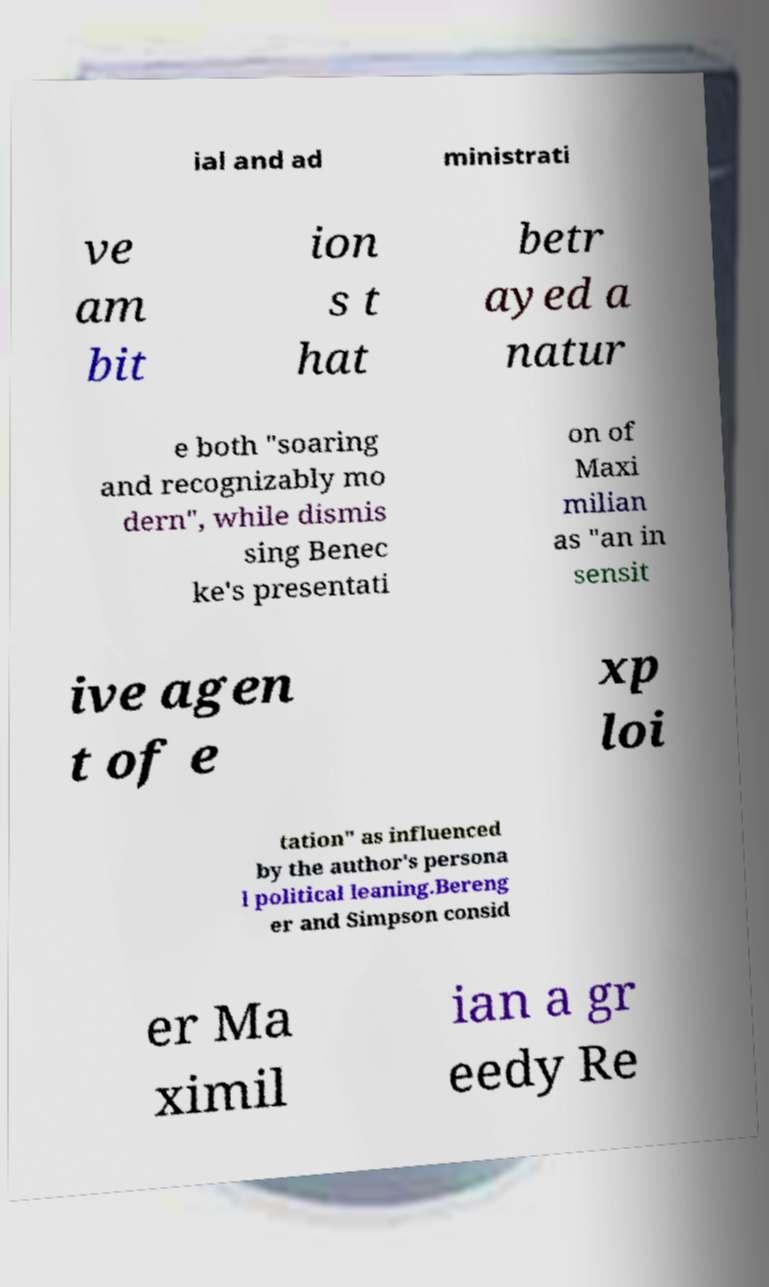For documentation purposes, I need the text within this image transcribed. Could you provide that? ial and ad ministrati ve am bit ion s t hat betr ayed a natur e both "soaring and recognizably mo dern", while dismis sing Benec ke's presentati on of Maxi milian as "an in sensit ive agen t of e xp loi tation" as influenced by the author's persona l political leaning.Bereng er and Simpson consid er Ma ximil ian a gr eedy Re 